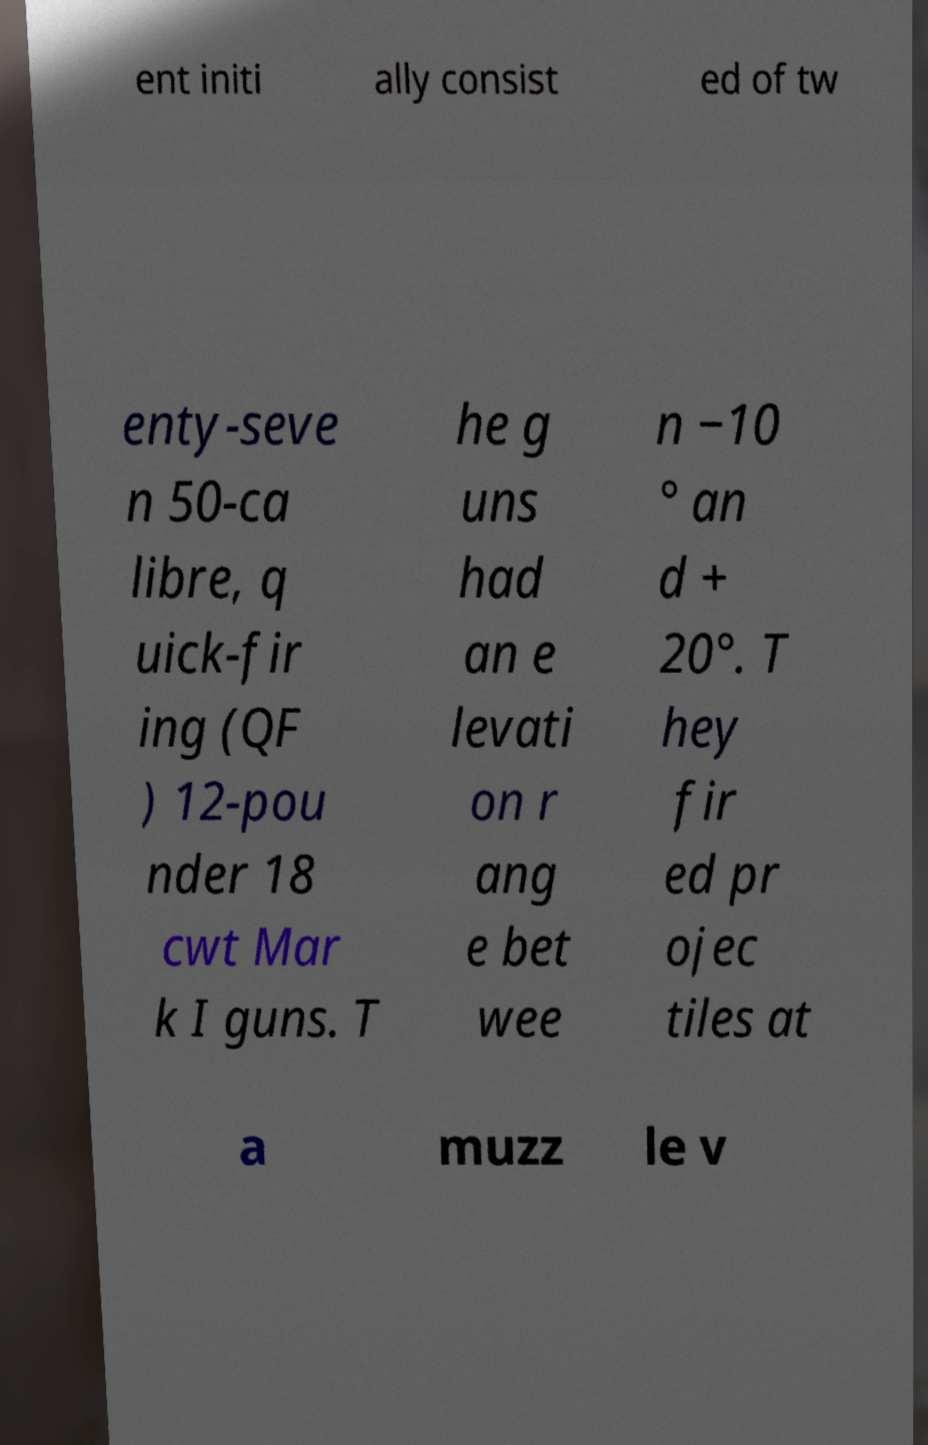What messages or text are displayed in this image? I need them in a readable, typed format. ent initi ally consist ed of tw enty-seve n 50-ca libre, q uick-fir ing (QF ) 12-pou nder 18 cwt Mar k I guns. T he g uns had an e levati on r ang e bet wee n −10 ° an d + 20°. T hey fir ed pr ojec tiles at a muzz le v 